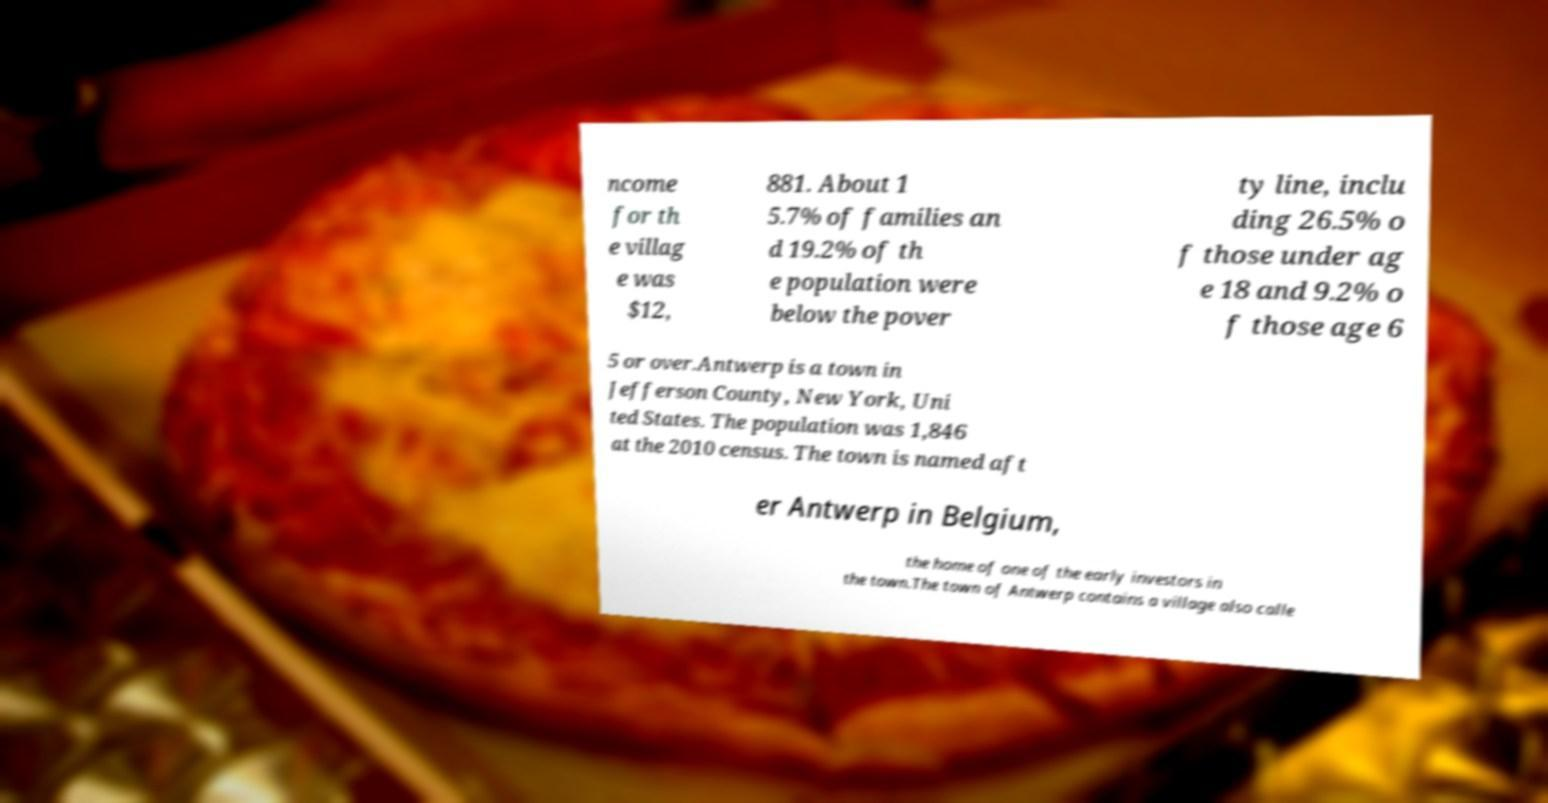Please identify and transcribe the text found in this image. ncome for th e villag e was $12, 881. About 1 5.7% of families an d 19.2% of th e population were below the pover ty line, inclu ding 26.5% o f those under ag e 18 and 9.2% o f those age 6 5 or over.Antwerp is a town in Jefferson County, New York, Uni ted States. The population was 1,846 at the 2010 census. The town is named aft er Antwerp in Belgium, the home of one of the early investors in the town.The town of Antwerp contains a village also calle 